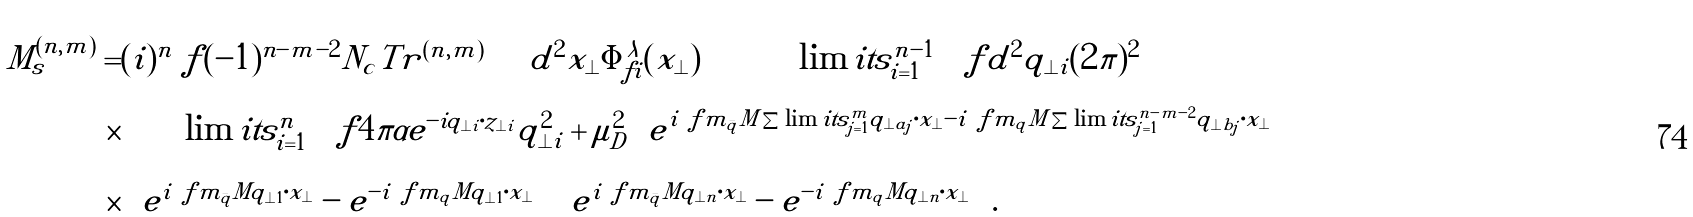<formula> <loc_0><loc_0><loc_500><loc_500>M ^ { ( n , m ) } _ { s } = & { ( i ) ^ { n } } \ f { ( - 1 ) ^ { n - m - 2 } } { N _ { c } } T r ^ { ( n , m ) } \int d ^ { 2 } x _ { \perp } \Phi ^ { \lambda } _ { f i } ( x _ { \perp } ) \int \prod \lim i t s _ { i = 1 } ^ { n - 1 } \left [ \ f { d ^ { 2 } q _ { \perp i } } { ( 2 \pi ) ^ { 2 } } \right ] \\ \times & \prod \lim i t s _ { i = 1 } ^ { n } \left [ \ f { 4 \pi \alpha e ^ { - i q _ { \perp i } \cdot z _ { \perp i } } } { q _ { \perp i } ^ { 2 } + \mu _ { D } ^ { 2 } } \right ] e ^ { i \ f { m _ { \bar { q } } } M \sum \lim i t s _ { j = 1 } ^ { m } q _ { \perp a _ { j } } \cdot x _ { \perp } - i \ f { m _ { q } } M \sum \lim i t s _ { j = 1 } ^ { n - m - 2 } q _ { \perp b _ { j } } \cdot x _ { \perp } } \\ \times & \left ( e ^ { i \ f { m _ { \bar { q } } } M q _ { \perp 1 } \cdot x _ { \perp } } - e ^ { - i \ f { m _ { q } } M q _ { \perp 1 } \cdot x _ { \perp } } \right ) \left ( e ^ { i \ f { m _ { \bar { q } } } M q _ { \perp n } \cdot x _ { \perp } } - e ^ { - i \ f { m _ { q } } M q _ { \perp n } \cdot x _ { \perp } } \right ) .</formula> 